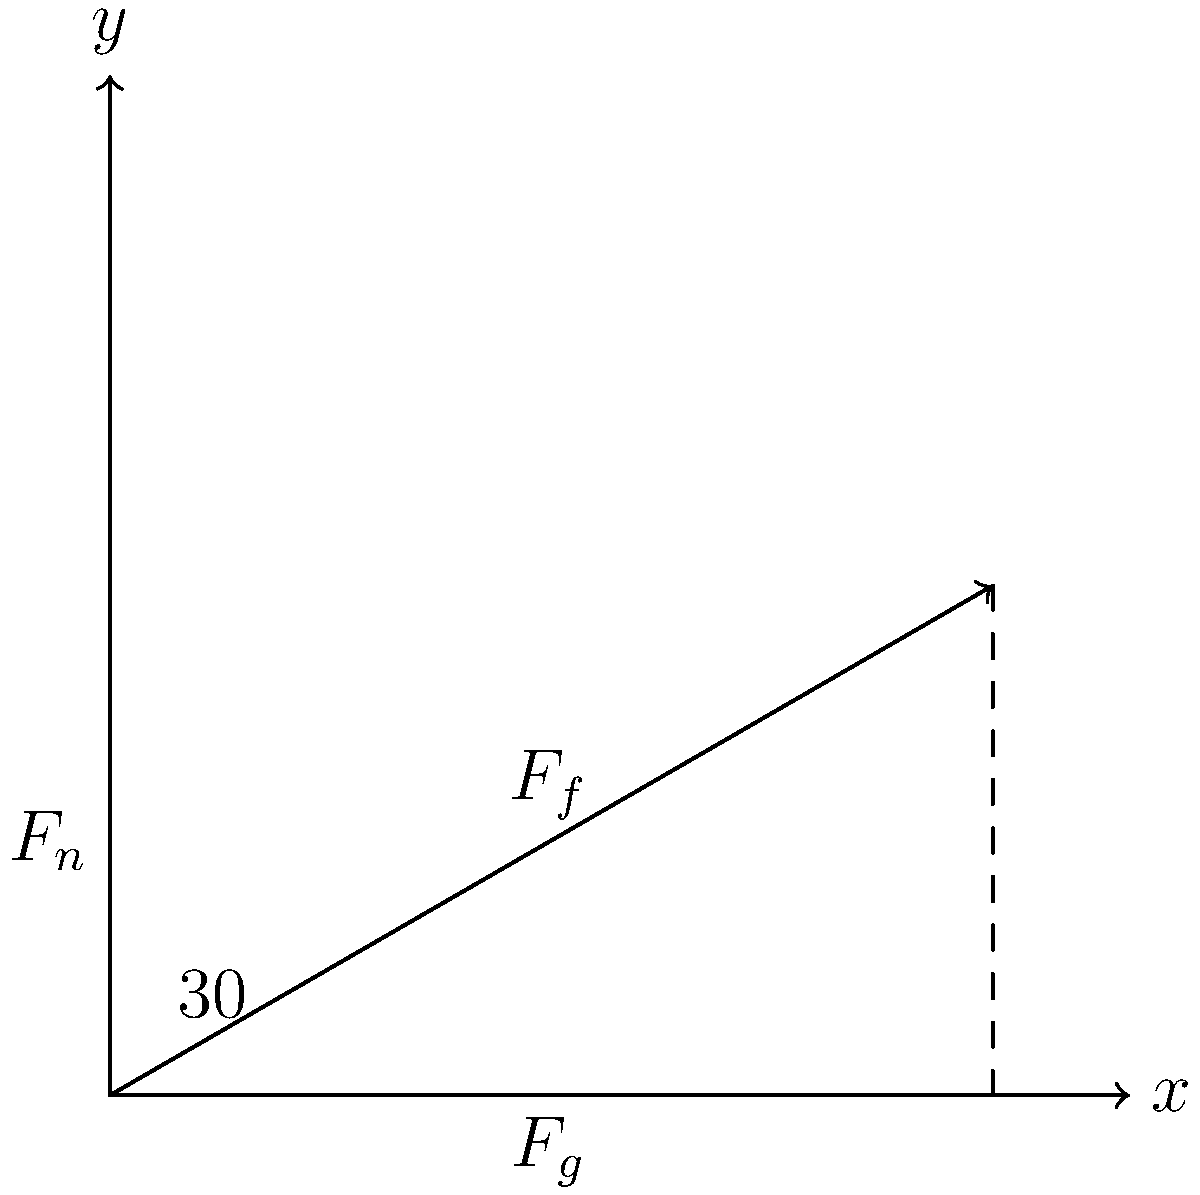During a crucial moment in the 1994-95 season game against the Manhattan Jaspers, you find yourself on a sloped section of the court. The slope makes an angle of 30° with the horizontal, and the coefficient of friction between your shoes and the court is 0.5. If your mass is 80 kg, what is the minimum force you need to apply parallel to the slope to start moving uphill? To solve this problem, we need to consider the forces acting on the player and use Newton's laws of motion. Let's break it down step-by-step:

1) First, let's identify the forces:
   - Weight (mg): acts downward
   - Normal force (F_n): perpendicular to the slope
   - Friction force (F_f): parallel to the slope, opposing motion
   - Applied force (F_a): parallel to the slope, in the direction of intended motion

2) Resolve the weight into components parallel and perpendicular to the slope:
   - Weight parallel to slope: $F_g_\parallel = mg \sin(30°)$
   - Weight perpendicular to slope: $F_g_\perp = mg \cos(30°)$

3) The normal force is equal to the perpendicular component of weight:
   $F_n = mg \cos(30°)$

4) The maximum static friction force is given by:
   $F_f = \mu F_n = \mu mg \cos(30°)$

5) For the player to start moving uphill, the applied force must overcome both the parallel component of weight and the friction force:
   $F_a = F_g_\parallel + F_f$

6) Substituting the values:
   $F_a = mg \sin(30°) + \mu mg \cos(30°)$
   $F_a = 80 \cdot 9.8 \cdot \sin(30°) + 0.5 \cdot 80 \cdot 9.8 \cdot \cos(30°)$
   $F_a = 392 \cdot 0.5 + 0.5 \cdot 392 \cdot 0.866$
   $F_a = 196 + 169.66$
   $F_a = 365.66$ N

Therefore, the minimum force needed to start moving uphill is approximately 365.66 N.
Answer: 365.66 N 